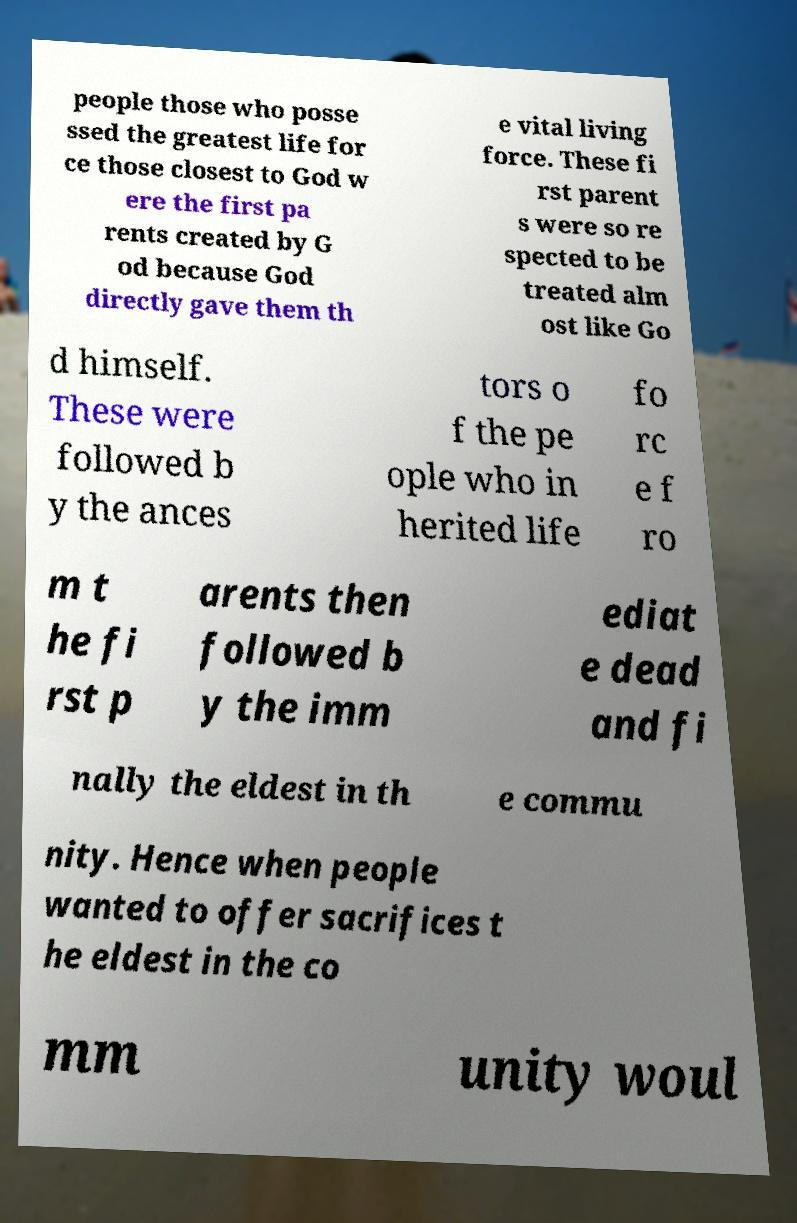There's text embedded in this image that I need extracted. Can you transcribe it verbatim? people those who posse ssed the greatest life for ce those closest to God w ere the first pa rents created by G od because God directly gave them th e vital living force. These fi rst parent s were so re spected to be treated alm ost like Go d himself. These were followed b y the ances tors o f the pe ople who in herited life fo rc e f ro m t he fi rst p arents then followed b y the imm ediat e dead and fi nally the eldest in th e commu nity. Hence when people wanted to offer sacrifices t he eldest in the co mm unity woul 